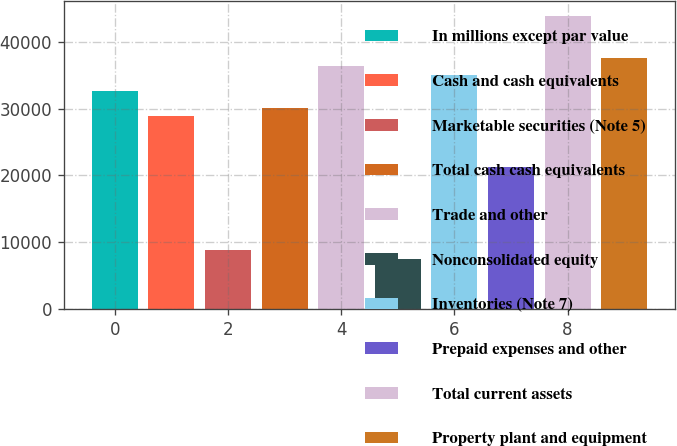<chart> <loc_0><loc_0><loc_500><loc_500><bar_chart><fcel>In millions except par value<fcel>Cash and cash equivalents<fcel>Marketable securities (Note 5)<fcel>Total cash cash equivalents<fcel>Trade and other<fcel>Nonconsolidated equity<fcel>Inventories (Note 7)<fcel>Prepaid expenses and other<fcel>Total current assets<fcel>Property plant and equipment<nl><fcel>32599.2<fcel>28839.6<fcel>8788.4<fcel>30092.8<fcel>36358.8<fcel>7535.2<fcel>35105.6<fcel>21320.4<fcel>43878<fcel>37612<nl></chart> 